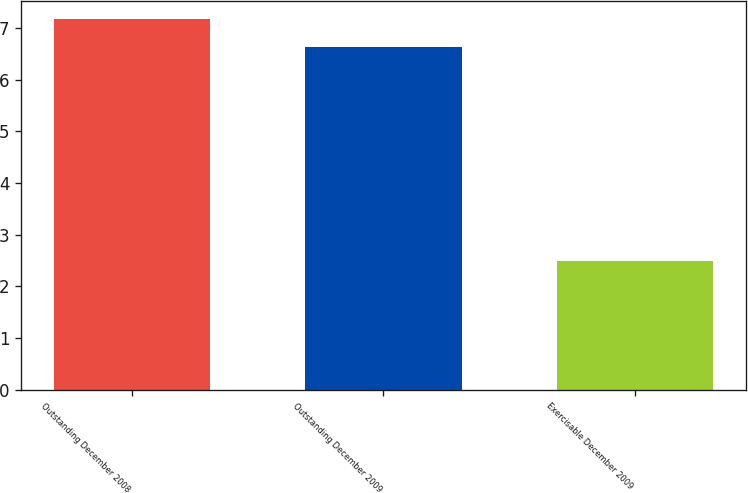Convert chart. <chart><loc_0><loc_0><loc_500><loc_500><bar_chart><fcel>Outstanding December 2008<fcel>Outstanding December 2009<fcel>Exercisable December 2009<nl><fcel>7.17<fcel>6.64<fcel>2.5<nl></chart> 